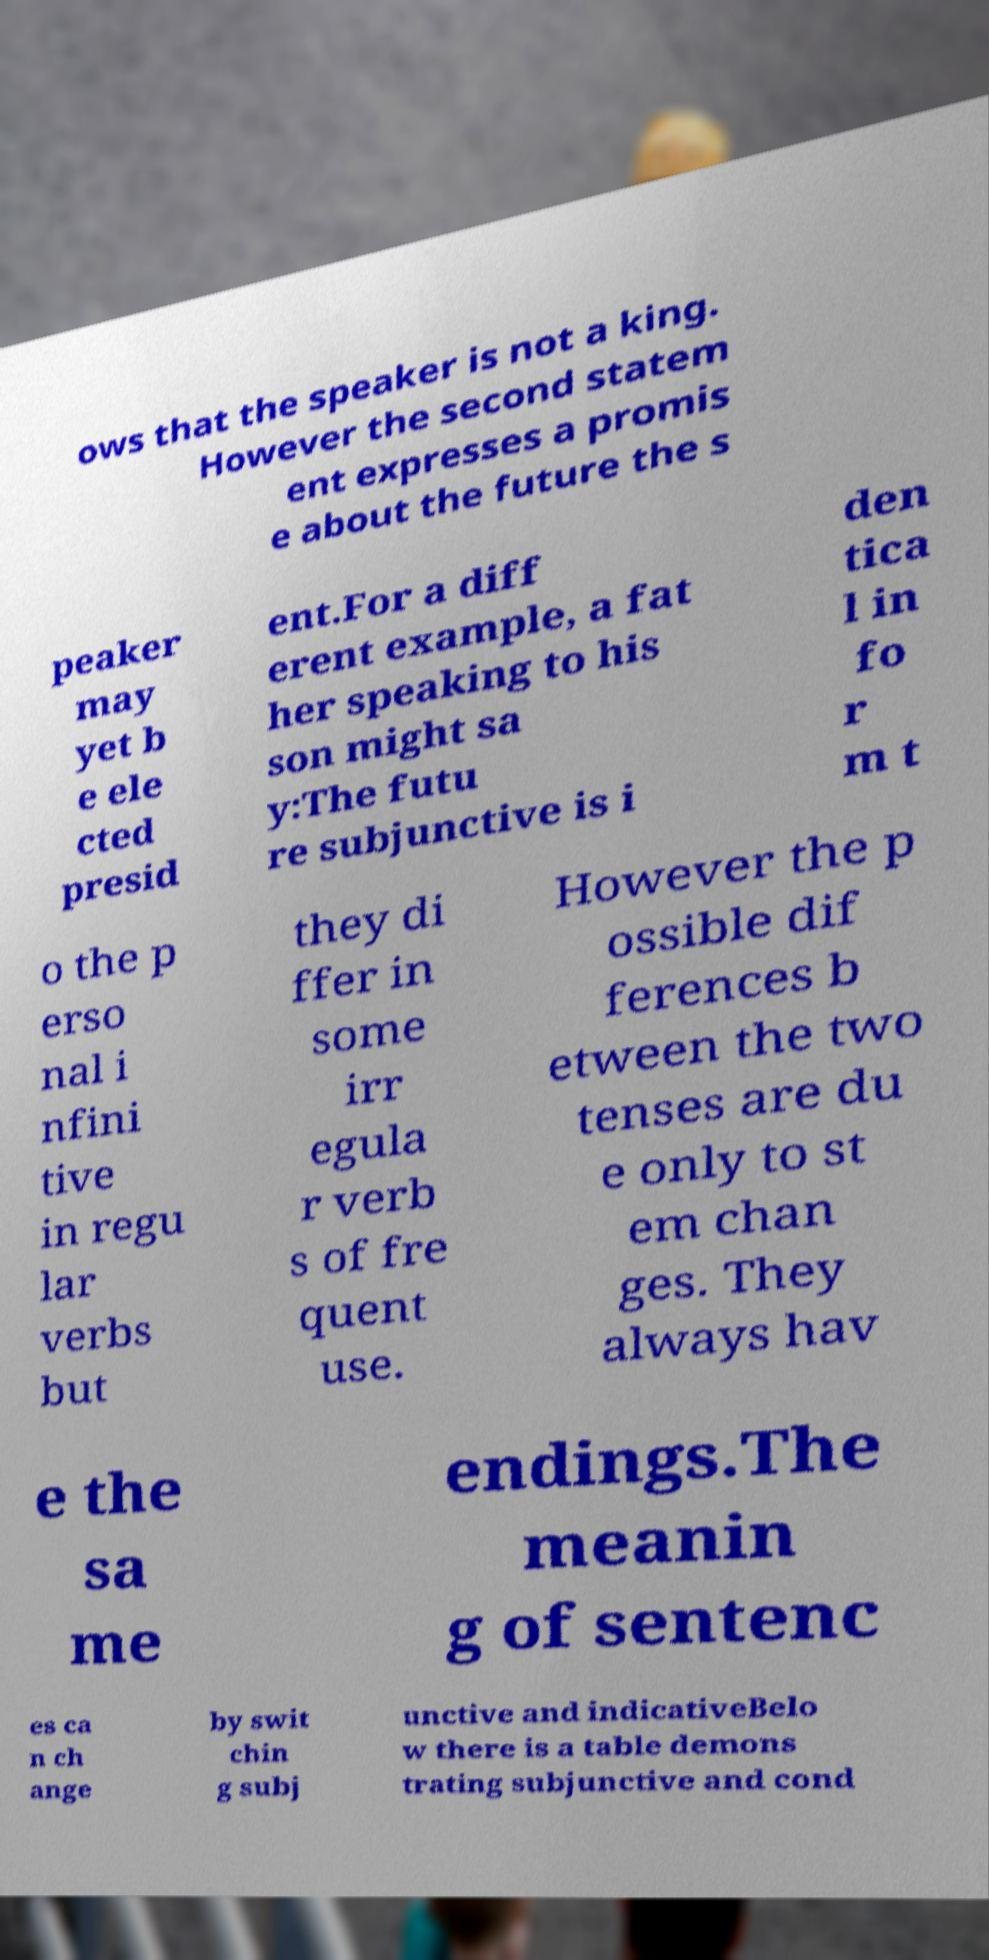There's text embedded in this image that I need extracted. Can you transcribe it verbatim? ows that the speaker is not a king. However the second statem ent expresses a promis e about the future the s peaker may yet b e ele cted presid ent.For a diff erent example, a fat her speaking to his son might sa y:The futu re subjunctive is i den tica l in fo r m t o the p erso nal i nfini tive in regu lar verbs but they di ffer in some irr egula r verb s of fre quent use. However the p ossible dif ferences b etween the two tenses are du e only to st em chan ges. They always hav e the sa me endings.The meanin g of sentenc es ca n ch ange by swit chin g subj unctive and indicativeBelo w there is a table demons trating subjunctive and cond 